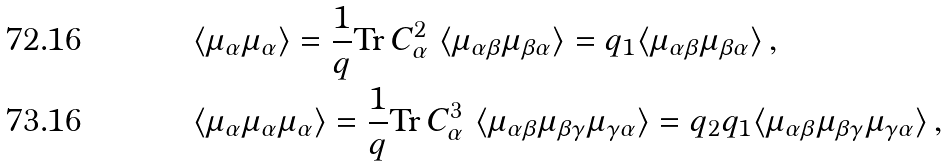<formula> <loc_0><loc_0><loc_500><loc_500>& \langle \mu _ { \alpha } \mu _ { \alpha } \rangle = \frac { 1 } { q } \text {Tr} \, C _ { \alpha } ^ { 2 } \text {  } \langle \mu _ { \alpha \beta } \mu _ { \beta \alpha } \rangle = q _ { 1 } \langle \mu _ { \alpha \beta } \mu _ { \beta \alpha } \rangle \, , \\ & \langle \mu _ { \alpha } \mu _ { \alpha } \mu _ { \alpha } \rangle = \frac { 1 } { q } \text {Tr} \, C _ { \alpha } ^ { 3 } \text {  } \langle \mu _ { \alpha \beta } \mu _ { \beta \gamma } \mu _ { \gamma \alpha } \rangle = q _ { 2 } q _ { 1 } \langle \mu _ { \alpha \beta } \mu _ { \beta \gamma } \mu _ { \gamma \alpha } \rangle \, ,</formula> 